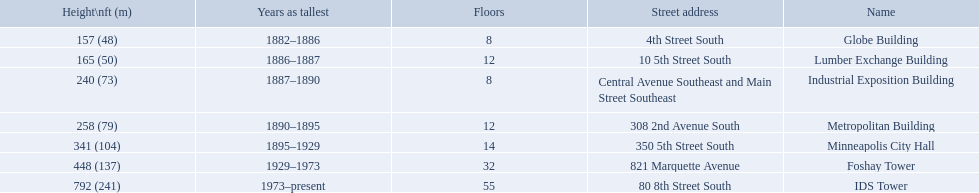How many floors does the globe building have? 8. Which building has 14 floors? Minneapolis City Hall. The lumber exchange building has the same number of floors as which building? Metropolitan Building. What are the tallest buildings in minneapolis? Globe Building, Lumber Exchange Building, Industrial Exposition Building, Metropolitan Building, Minneapolis City Hall, Foshay Tower, IDS Tower. Which of those have 8 floors? Globe Building, Industrial Exposition Building. Of those, which is 240 ft tall? Industrial Exposition Building. How tall is the metropolitan building? 258 (79). How tall is the lumber exchange building? 165 (50). Is the metropolitan or lumber exchange building taller? Metropolitan Building. 